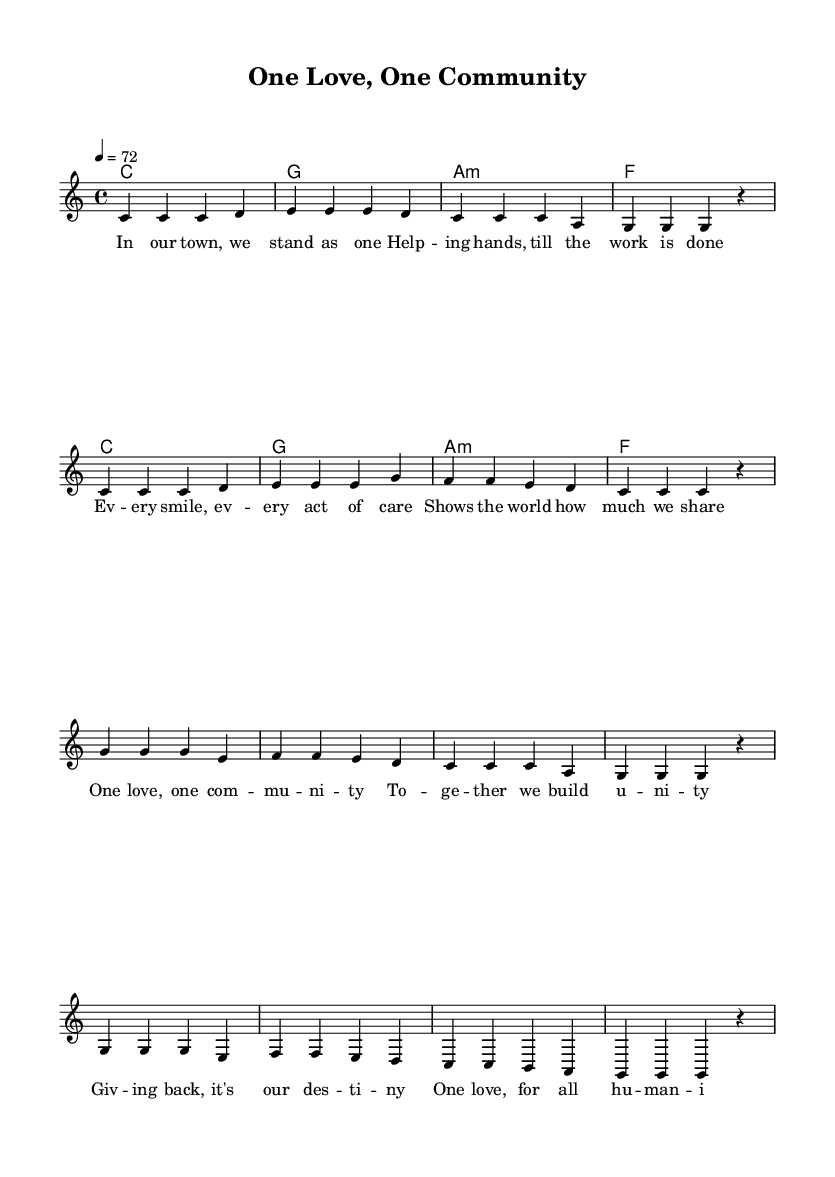What is the key signature of this music? The key signature is indicated at the beginning of the sheet music, and it shows that there are no sharps or flats, which corresponds to the key of C major.
Answer: C major What is the time signature of this piece? The time signature is displayed at the start of the music, showing a fraction that indicates how many beats are in each measure. In this case, it is 4/4, meaning there are four beats per measure, and a quarter note gets one beat.
Answer: 4/4 What is the tempo marking for this song? The tempo is specified in beats per minute (BPM) right after the time signature. Here, the indication shows that the tempo of the piece is set at 72 beats per minute.
Answer: 72 What are the first two words of the verse? The lyrics for the verse are presented under the melody. The first two words at the beginning of the verse are "In our."
Answer: In our How many measures are in the chorus section? The chorus section is found in a specific part of the sheet music, visually separated from the verse section. Counting the measures in the chorus, there are four distinct measures.
Answer: 4 How does the chorus relate to the theme of community support? By analyzing the lyrics of the chorus and the overall context of the piece, it expresses a unified message about love and support, emphasizing togetherness and the commitment to give back, all central themes in community support.
Answer: Togetherness and support What type of harmony is used in this piece? The harmony is specified in the chord section, and it indicates simple major and minor chords typically used in reggae music for a light and uplifting sound. The chords used are C major, G major, A minor, and F major.
Answer: Major and minor chords 